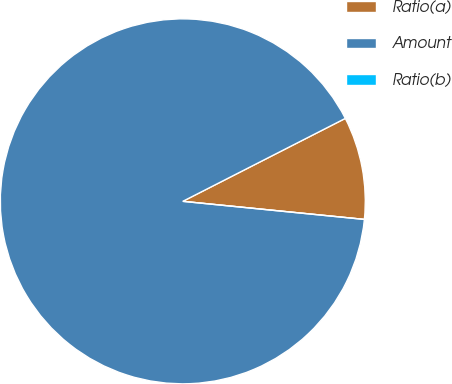<chart> <loc_0><loc_0><loc_500><loc_500><pie_chart><fcel>Ratio(a)<fcel>Amount<fcel>Ratio(b)<nl><fcel>9.09%<fcel>90.91%<fcel>0.0%<nl></chart> 